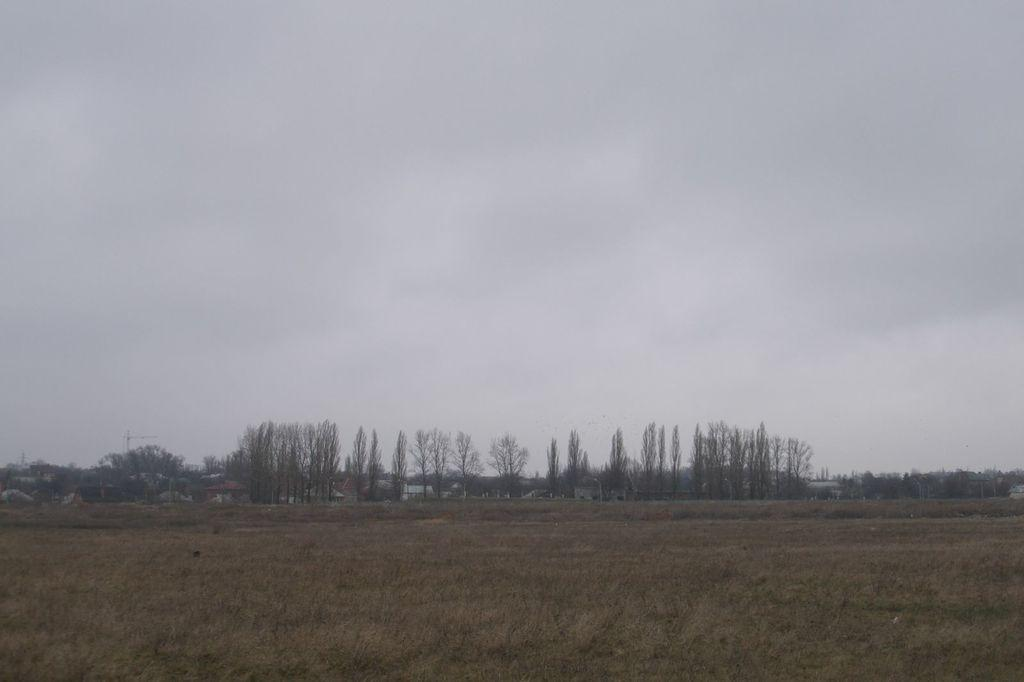What type of vegetation can be seen in the image? There are trees in the image. What else can be seen growing in the image? There is grass in the image. What type of structures are visible in the image? There are houses in the image. What is visible above the trees and houses in the image? The sky is visible in the image. What type of glass is being used for care in the image? There is no glass or care-related activity present in the image. 